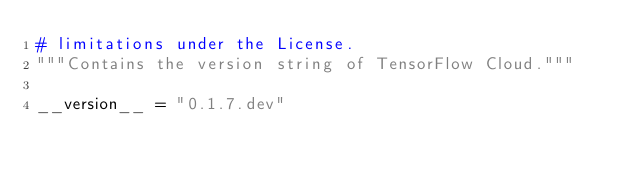Convert code to text. <code><loc_0><loc_0><loc_500><loc_500><_Python_># limitations under the License.
"""Contains the version string of TensorFlow Cloud."""

__version__ = "0.1.7.dev"
</code> 